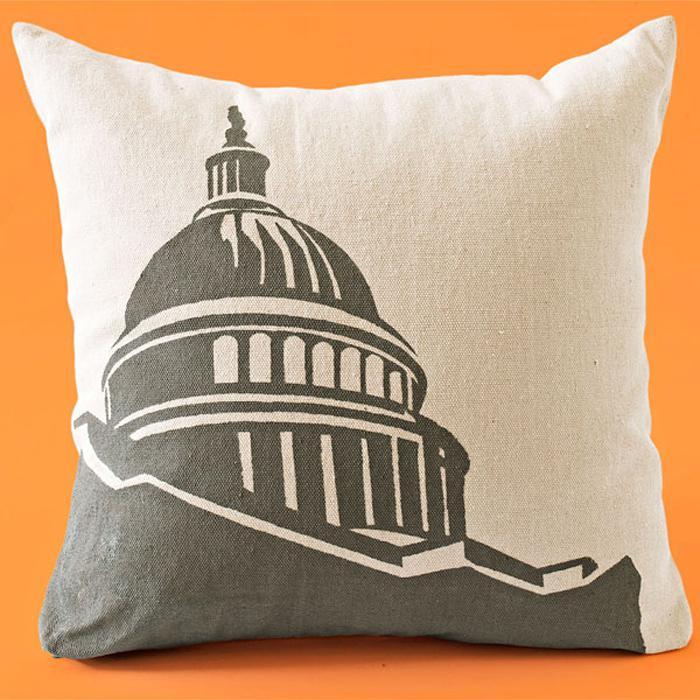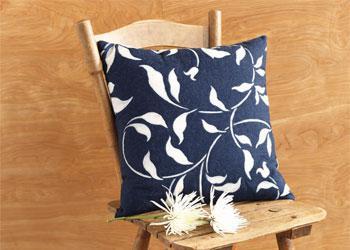The first image is the image on the left, the second image is the image on the right. Evaluate the accuracy of this statement regarding the images: "One of the images has at least part of its pillow decoration written mostly in black ink.". Is it true? Answer yes or no. No. The first image is the image on the left, the second image is the image on the right. Examine the images to the left and right. Is the description "There are at least 2 pillows in the right image." accurate? Answer yes or no. No. 